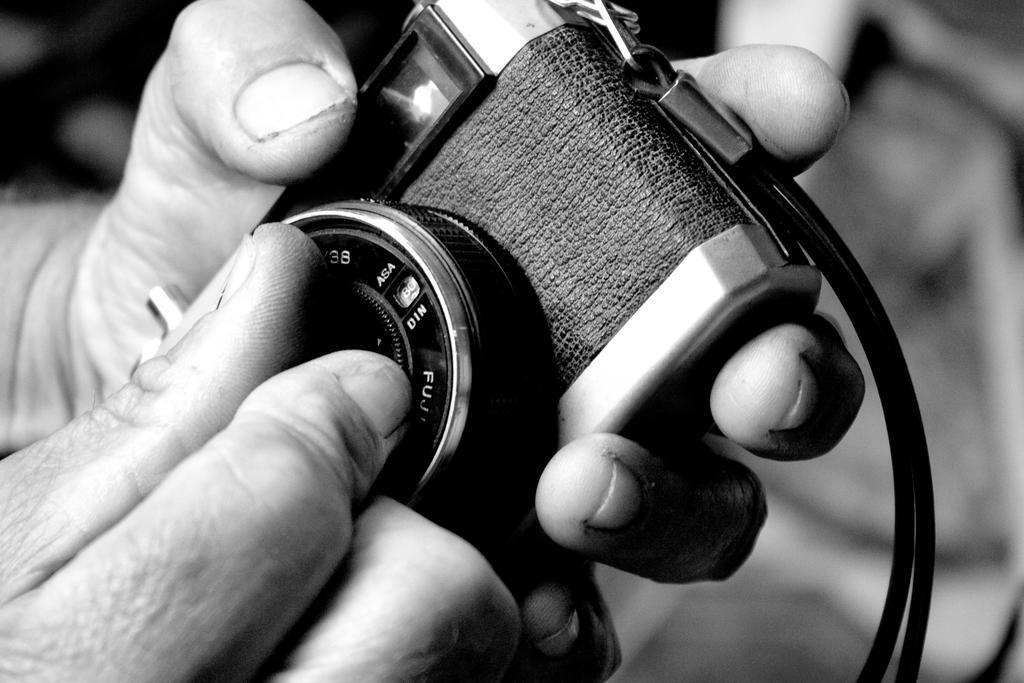How would you summarize this image in a sentence or two? In this picture I can see there is a person holding the camera and he is adjusting the lens and the lens are in black color and the backdrop is clear. 